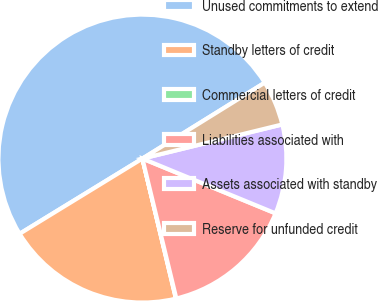Convert chart. <chart><loc_0><loc_0><loc_500><loc_500><pie_chart><fcel>Unused commitments to extend<fcel>Standby letters of credit<fcel>Commercial letters of credit<fcel>Liabilities associated with<fcel>Assets associated with standby<fcel>Reserve for unfunded credit<nl><fcel>49.9%<fcel>19.99%<fcel>0.05%<fcel>15.0%<fcel>10.02%<fcel>5.03%<nl></chart> 